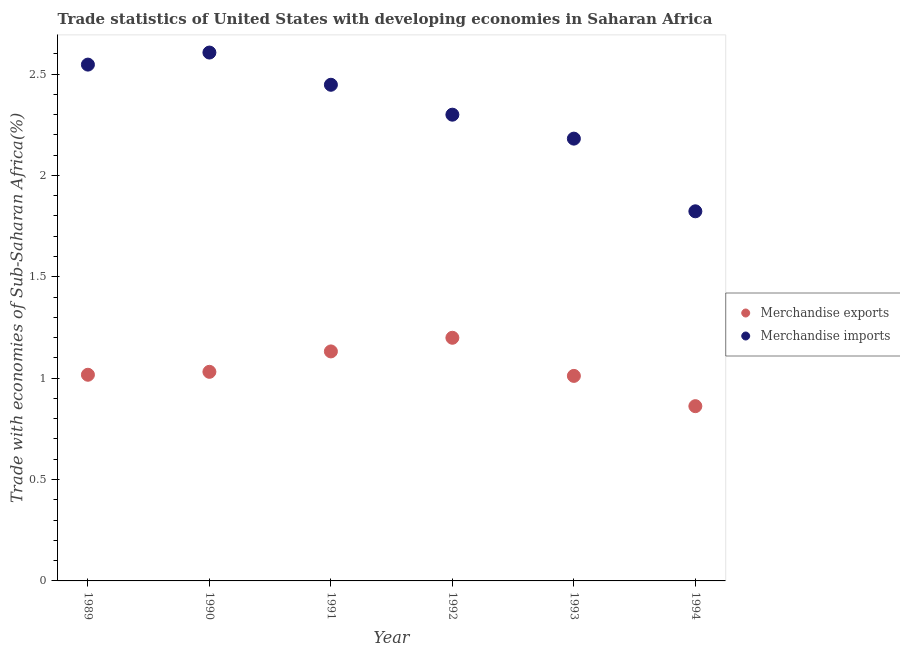How many different coloured dotlines are there?
Keep it short and to the point. 2. What is the merchandise exports in 1990?
Keep it short and to the point. 1.03. Across all years, what is the maximum merchandise imports?
Offer a terse response. 2.61. Across all years, what is the minimum merchandise exports?
Your response must be concise. 0.86. What is the total merchandise imports in the graph?
Offer a terse response. 13.9. What is the difference between the merchandise exports in 1991 and that in 1994?
Your answer should be very brief. 0.27. What is the difference between the merchandise exports in 1992 and the merchandise imports in 1991?
Make the answer very short. -1.25. What is the average merchandise exports per year?
Provide a short and direct response. 1.04. In the year 1992, what is the difference between the merchandise exports and merchandise imports?
Keep it short and to the point. -1.1. What is the ratio of the merchandise exports in 1989 to that in 1993?
Your answer should be compact. 1.01. Is the merchandise imports in 1989 less than that in 1994?
Your answer should be very brief. No. Is the difference between the merchandise exports in 1989 and 1992 greater than the difference between the merchandise imports in 1989 and 1992?
Keep it short and to the point. No. What is the difference between the highest and the second highest merchandise imports?
Offer a terse response. 0.06. What is the difference between the highest and the lowest merchandise imports?
Keep it short and to the point. 0.78. In how many years, is the merchandise exports greater than the average merchandise exports taken over all years?
Your response must be concise. 2. Is the merchandise imports strictly less than the merchandise exports over the years?
Make the answer very short. No. How many years are there in the graph?
Your answer should be very brief. 6. How many legend labels are there?
Make the answer very short. 2. How are the legend labels stacked?
Keep it short and to the point. Vertical. What is the title of the graph?
Provide a short and direct response. Trade statistics of United States with developing economies in Saharan Africa. What is the label or title of the Y-axis?
Offer a very short reply. Trade with economies of Sub-Saharan Africa(%). What is the Trade with economies of Sub-Saharan Africa(%) in Merchandise exports in 1989?
Your answer should be very brief. 1.02. What is the Trade with economies of Sub-Saharan Africa(%) in Merchandise imports in 1989?
Your answer should be very brief. 2.55. What is the Trade with economies of Sub-Saharan Africa(%) of Merchandise exports in 1990?
Give a very brief answer. 1.03. What is the Trade with economies of Sub-Saharan Africa(%) of Merchandise imports in 1990?
Make the answer very short. 2.61. What is the Trade with economies of Sub-Saharan Africa(%) of Merchandise exports in 1991?
Give a very brief answer. 1.13. What is the Trade with economies of Sub-Saharan Africa(%) of Merchandise imports in 1991?
Your response must be concise. 2.45. What is the Trade with economies of Sub-Saharan Africa(%) in Merchandise exports in 1992?
Offer a very short reply. 1.2. What is the Trade with economies of Sub-Saharan Africa(%) in Merchandise imports in 1992?
Offer a terse response. 2.3. What is the Trade with economies of Sub-Saharan Africa(%) in Merchandise exports in 1993?
Provide a short and direct response. 1.01. What is the Trade with economies of Sub-Saharan Africa(%) of Merchandise imports in 1993?
Your answer should be compact. 2.18. What is the Trade with economies of Sub-Saharan Africa(%) in Merchandise exports in 1994?
Your response must be concise. 0.86. What is the Trade with economies of Sub-Saharan Africa(%) in Merchandise imports in 1994?
Keep it short and to the point. 1.82. Across all years, what is the maximum Trade with economies of Sub-Saharan Africa(%) of Merchandise exports?
Give a very brief answer. 1.2. Across all years, what is the maximum Trade with economies of Sub-Saharan Africa(%) of Merchandise imports?
Keep it short and to the point. 2.61. Across all years, what is the minimum Trade with economies of Sub-Saharan Africa(%) in Merchandise exports?
Offer a very short reply. 0.86. Across all years, what is the minimum Trade with economies of Sub-Saharan Africa(%) in Merchandise imports?
Ensure brevity in your answer.  1.82. What is the total Trade with economies of Sub-Saharan Africa(%) in Merchandise exports in the graph?
Make the answer very short. 6.25. What is the total Trade with economies of Sub-Saharan Africa(%) of Merchandise imports in the graph?
Keep it short and to the point. 13.9. What is the difference between the Trade with economies of Sub-Saharan Africa(%) in Merchandise exports in 1989 and that in 1990?
Your answer should be compact. -0.01. What is the difference between the Trade with economies of Sub-Saharan Africa(%) in Merchandise imports in 1989 and that in 1990?
Offer a very short reply. -0.06. What is the difference between the Trade with economies of Sub-Saharan Africa(%) of Merchandise exports in 1989 and that in 1991?
Make the answer very short. -0.12. What is the difference between the Trade with economies of Sub-Saharan Africa(%) in Merchandise imports in 1989 and that in 1991?
Keep it short and to the point. 0.1. What is the difference between the Trade with economies of Sub-Saharan Africa(%) in Merchandise exports in 1989 and that in 1992?
Make the answer very short. -0.18. What is the difference between the Trade with economies of Sub-Saharan Africa(%) of Merchandise imports in 1989 and that in 1992?
Keep it short and to the point. 0.25. What is the difference between the Trade with economies of Sub-Saharan Africa(%) in Merchandise exports in 1989 and that in 1993?
Offer a very short reply. 0.01. What is the difference between the Trade with economies of Sub-Saharan Africa(%) of Merchandise imports in 1989 and that in 1993?
Keep it short and to the point. 0.37. What is the difference between the Trade with economies of Sub-Saharan Africa(%) of Merchandise exports in 1989 and that in 1994?
Keep it short and to the point. 0.15. What is the difference between the Trade with economies of Sub-Saharan Africa(%) of Merchandise imports in 1989 and that in 1994?
Offer a terse response. 0.72. What is the difference between the Trade with economies of Sub-Saharan Africa(%) in Merchandise exports in 1990 and that in 1991?
Offer a terse response. -0.1. What is the difference between the Trade with economies of Sub-Saharan Africa(%) in Merchandise imports in 1990 and that in 1991?
Make the answer very short. 0.16. What is the difference between the Trade with economies of Sub-Saharan Africa(%) of Merchandise exports in 1990 and that in 1992?
Your answer should be compact. -0.17. What is the difference between the Trade with economies of Sub-Saharan Africa(%) in Merchandise imports in 1990 and that in 1992?
Your response must be concise. 0.31. What is the difference between the Trade with economies of Sub-Saharan Africa(%) of Merchandise exports in 1990 and that in 1993?
Keep it short and to the point. 0.02. What is the difference between the Trade with economies of Sub-Saharan Africa(%) of Merchandise imports in 1990 and that in 1993?
Your answer should be compact. 0.42. What is the difference between the Trade with economies of Sub-Saharan Africa(%) of Merchandise exports in 1990 and that in 1994?
Your answer should be compact. 0.17. What is the difference between the Trade with economies of Sub-Saharan Africa(%) in Merchandise imports in 1990 and that in 1994?
Offer a terse response. 0.78. What is the difference between the Trade with economies of Sub-Saharan Africa(%) of Merchandise exports in 1991 and that in 1992?
Your answer should be very brief. -0.07. What is the difference between the Trade with economies of Sub-Saharan Africa(%) of Merchandise imports in 1991 and that in 1992?
Give a very brief answer. 0.15. What is the difference between the Trade with economies of Sub-Saharan Africa(%) in Merchandise exports in 1991 and that in 1993?
Give a very brief answer. 0.12. What is the difference between the Trade with economies of Sub-Saharan Africa(%) of Merchandise imports in 1991 and that in 1993?
Your response must be concise. 0.27. What is the difference between the Trade with economies of Sub-Saharan Africa(%) in Merchandise exports in 1991 and that in 1994?
Your response must be concise. 0.27. What is the difference between the Trade with economies of Sub-Saharan Africa(%) in Merchandise imports in 1991 and that in 1994?
Offer a very short reply. 0.62. What is the difference between the Trade with economies of Sub-Saharan Africa(%) of Merchandise exports in 1992 and that in 1993?
Keep it short and to the point. 0.19. What is the difference between the Trade with economies of Sub-Saharan Africa(%) in Merchandise imports in 1992 and that in 1993?
Your response must be concise. 0.12. What is the difference between the Trade with economies of Sub-Saharan Africa(%) of Merchandise exports in 1992 and that in 1994?
Give a very brief answer. 0.34. What is the difference between the Trade with economies of Sub-Saharan Africa(%) of Merchandise imports in 1992 and that in 1994?
Ensure brevity in your answer.  0.48. What is the difference between the Trade with economies of Sub-Saharan Africa(%) in Merchandise exports in 1993 and that in 1994?
Keep it short and to the point. 0.15. What is the difference between the Trade with economies of Sub-Saharan Africa(%) in Merchandise imports in 1993 and that in 1994?
Provide a succinct answer. 0.36. What is the difference between the Trade with economies of Sub-Saharan Africa(%) of Merchandise exports in 1989 and the Trade with economies of Sub-Saharan Africa(%) of Merchandise imports in 1990?
Your answer should be compact. -1.59. What is the difference between the Trade with economies of Sub-Saharan Africa(%) of Merchandise exports in 1989 and the Trade with economies of Sub-Saharan Africa(%) of Merchandise imports in 1991?
Offer a very short reply. -1.43. What is the difference between the Trade with economies of Sub-Saharan Africa(%) in Merchandise exports in 1989 and the Trade with economies of Sub-Saharan Africa(%) in Merchandise imports in 1992?
Keep it short and to the point. -1.28. What is the difference between the Trade with economies of Sub-Saharan Africa(%) of Merchandise exports in 1989 and the Trade with economies of Sub-Saharan Africa(%) of Merchandise imports in 1993?
Your answer should be very brief. -1.16. What is the difference between the Trade with economies of Sub-Saharan Africa(%) of Merchandise exports in 1989 and the Trade with economies of Sub-Saharan Africa(%) of Merchandise imports in 1994?
Provide a succinct answer. -0.81. What is the difference between the Trade with economies of Sub-Saharan Africa(%) in Merchandise exports in 1990 and the Trade with economies of Sub-Saharan Africa(%) in Merchandise imports in 1991?
Offer a terse response. -1.42. What is the difference between the Trade with economies of Sub-Saharan Africa(%) in Merchandise exports in 1990 and the Trade with economies of Sub-Saharan Africa(%) in Merchandise imports in 1992?
Your answer should be very brief. -1.27. What is the difference between the Trade with economies of Sub-Saharan Africa(%) in Merchandise exports in 1990 and the Trade with economies of Sub-Saharan Africa(%) in Merchandise imports in 1993?
Your answer should be compact. -1.15. What is the difference between the Trade with economies of Sub-Saharan Africa(%) of Merchandise exports in 1990 and the Trade with economies of Sub-Saharan Africa(%) of Merchandise imports in 1994?
Ensure brevity in your answer.  -0.79. What is the difference between the Trade with economies of Sub-Saharan Africa(%) of Merchandise exports in 1991 and the Trade with economies of Sub-Saharan Africa(%) of Merchandise imports in 1992?
Your response must be concise. -1.17. What is the difference between the Trade with economies of Sub-Saharan Africa(%) of Merchandise exports in 1991 and the Trade with economies of Sub-Saharan Africa(%) of Merchandise imports in 1993?
Your answer should be very brief. -1.05. What is the difference between the Trade with economies of Sub-Saharan Africa(%) in Merchandise exports in 1991 and the Trade with economies of Sub-Saharan Africa(%) in Merchandise imports in 1994?
Your answer should be compact. -0.69. What is the difference between the Trade with economies of Sub-Saharan Africa(%) in Merchandise exports in 1992 and the Trade with economies of Sub-Saharan Africa(%) in Merchandise imports in 1993?
Provide a succinct answer. -0.98. What is the difference between the Trade with economies of Sub-Saharan Africa(%) of Merchandise exports in 1992 and the Trade with economies of Sub-Saharan Africa(%) of Merchandise imports in 1994?
Provide a succinct answer. -0.62. What is the difference between the Trade with economies of Sub-Saharan Africa(%) in Merchandise exports in 1993 and the Trade with economies of Sub-Saharan Africa(%) in Merchandise imports in 1994?
Give a very brief answer. -0.81. What is the average Trade with economies of Sub-Saharan Africa(%) of Merchandise exports per year?
Offer a terse response. 1.04. What is the average Trade with economies of Sub-Saharan Africa(%) in Merchandise imports per year?
Ensure brevity in your answer.  2.32. In the year 1989, what is the difference between the Trade with economies of Sub-Saharan Africa(%) of Merchandise exports and Trade with economies of Sub-Saharan Africa(%) of Merchandise imports?
Your response must be concise. -1.53. In the year 1990, what is the difference between the Trade with economies of Sub-Saharan Africa(%) in Merchandise exports and Trade with economies of Sub-Saharan Africa(%) in Merchandise imports?
Make the answer very short. -1.57. In the year 1991, what is the difference between the Trade with economies of Sub-Saharan Africa(%) of Merchandise exports and Trade with economies of Sub-Saharan Africa(%) of Merchandise imports?
Your answer should be very brief. -1.32. In the year 1992, what is the difference between the Trade with economies of Sub-Saharan Africa(%) in Merchandise exports and Trade with economies of Sub-Saharan Africa(%) in Merchandise imports?
Your response must be concise. -1.1. In the year 1993, what is the difference between the Trade with economies of Sub-Saharan Africa(%) in Merchandise exports and Trade with economies of Sub-Saharan Africa(%) in Merchandise imports?
Provide a succinct answer. -1.17. In the year 1994, what is the difference between the Trade with economies of Sub-Saharan Africa(%) in Merchandise exports and Trade with economies of Sub-Saharan Africa(%) in Merchandise imports?
Provide a short and direct response. -0.96. What is the ratio of the Trade with economies of Sub-Saharan Africa(%) in Merchandise exports in 1989 to that in 1990?
Ensure brevity in your answer.  0.99. What is the ratio of the Trade with economies of Sub-Saharan Africa(%) of Merchandise imports in 1989 to that in 1990?
Offer a terse response. 0.98. What is the ratio of the Trade with economies of Sub-Saharan Africa(%) in Merchandise exports in 1989 to that in 1991?
Ensure brevity in your answer.  0.9. What is the ratio of the Trade with economies of Sub-Saharan Africa(%) of Merchandise imports in 1989 to that in 1991?
Provide a succinct answer. 1.04. What is the ratio of the Trade with economies of Sub-Saharan Africa(%) in Merchandise exports in 1989 to that in 1992?
Provide a succinct answer. 0.85. What is the ratio of the Trade with economies of Sub-Saharan Africa(%) of Merchandise imports in 1989 to that in 1992?
Ensure brevity in your answer.  1.11. What is the ratio of the Trade with economies of Sub-Saharan Africa(%) in Merchandise exports in 1989 to that in 1993?
Provide a succinct answer. 1.01. What is the ratio of the Trade with economies of Sub-Saharan Africa(%) in Merchandise imports in 1989 to that in 1993?
Ensure brevity in your answer.  1.17. What is the ratio of the Trade with economies of Sub-Saharan Africa(%) in Merchandise exports in 1989 to that in 1994?
Provide a succinct answer. 1.18. What is the ratio of the Trade with economies of Sub-Saharan Africa(%) of Merchandise imports in 1989 to that in 1994?
Provide a succinct answer. 1.4. What is the ratio of the Trade with economies of Sub-Saharan Africa(%) in Merchandise exports in 1990 to that in 1991?
Make the answer very short. 0.91. What is the ratio of the Trade with economies of Sub-Saharan Africa(%) of Merchandise imports in 1990 to that in 1991?
Your answer should be compact. 1.06. What is the ratio of the Trade with economies of Sub-Saharan Africa(%) in Merchandise exports in 1990 to that in 1992?
Your answer should be very brief. 0.86. What is the ratio of the Trade with economies of Sub-Saharan Africa(%) of Merchandise imports in 1990 to that in 1992?
Offer a very short reply. 1.13. What is the ratio of the Trade with economies of Sub-Saharan Africa(%) in Merchandise exports in 1990 to that in 1993?
Your answer should be compact. 1.02. What is the ratio of the Trade with economies of Sub-Saharan Africa(%) of Merchandise imports in 1990 to that in 1993?
Offer a very short reply. 1.19. What is the ratio of the Trade with economies of Sub-Saharan Africa(%) of Merchandise exports in 1990 to that in 1994?
Your answer should be compact. 1.2. What is the ratio of the Trade with economies of Sub-Saharan Africa(%) of Merchandise imports in 1990 to that in 1994?
Offer a terse response. 1.43. What is the ratio of the Trade with economies of Sub-Saharan Africa(%) in Merchandise exports in 1991 to that in 1992?
Your answer should be very brief. 0.94. What is the ratio of the Trade with economies of Sub-Saharan Africa(%) of Merchandise imports in 1991 to that in 1992?
Ensure brevity in your answer.  1.06. What is the ratio of the Trade with economies of Sub-Saharan Africa(%) of Merchandise exports in 1991 to that in 1993?
Offer a terse response. 1.12. What is the ratio of the Trade with economies of Sub-Saharan Africa(%) in Merchandise imports in 1991 to that in 1993?
Make the answer very short. 1.12. What is the ratio of the Trade with economies of Sub-Saharan Africa(%) in Merchandise exports in 1991 to that in 1994?
Offer a very short reply. 1.31. What is the ratio of the Trade with economies of Sub-Saharan Africa(%) of Merchandise imports in 1991 to that in 1994?
Ensure brevity in your answer.  1.34. What is the ratio of the Trade with economies of Sub-Saharan Africa(%) of Merchandise exports in 1992 to that in 1993?
Provide a succinct answer. 1.19. What is the ratio of the Trade with economies of Sub-Saharan Africa(%) of Merchandise imports in 1992 to that in 1993?
Give a very brief answer. 1.05. What is the ratio of the Trade with economies of Sub-Saharan Africa(%) in Merchandise exports in 1992 to that in 1994?
Your answer should be compact. 1.39. What is the ratio of the Trade with economies of Sub-Saharan Africa(%) in Merchandise imports in 1992 to that in 1994?
Keep it short and to the point. 1.26. What is the ratio of the Trade with economies of Sub-Saharan Africa(%) in Merchandise exports in 1993 to that in 1994?
Your answer should be compact. 1.17. What is the ratio of the Trade with economies of Sub-Saharan Africa(%) in Merchandise imports in 1993 to that in 1994?
Ensure brevity in your answer.  1.2. What is the difference between the highest and the second highest Trade with economies of Sub-Saharan Africa(%) of Merchandise exports?
Your answer should be compact. 0.07. What is the difference between the highest and the second highest Trade with economies of Sub-Saharan Africa(%) of Merchandise imports?
Your answer should be very brief. 0.06. What is the difference between the highest and the lowest Trade with economies of Sub-Saharan Africa(%) of Merchandise exports?
Provide a short and direct response. 0.34. What is the difference between the highest and the lowest Trade with economies of Sub-Saharan Africa(%) of Merchandise imports?
Your answer should be compact. 0.78. 